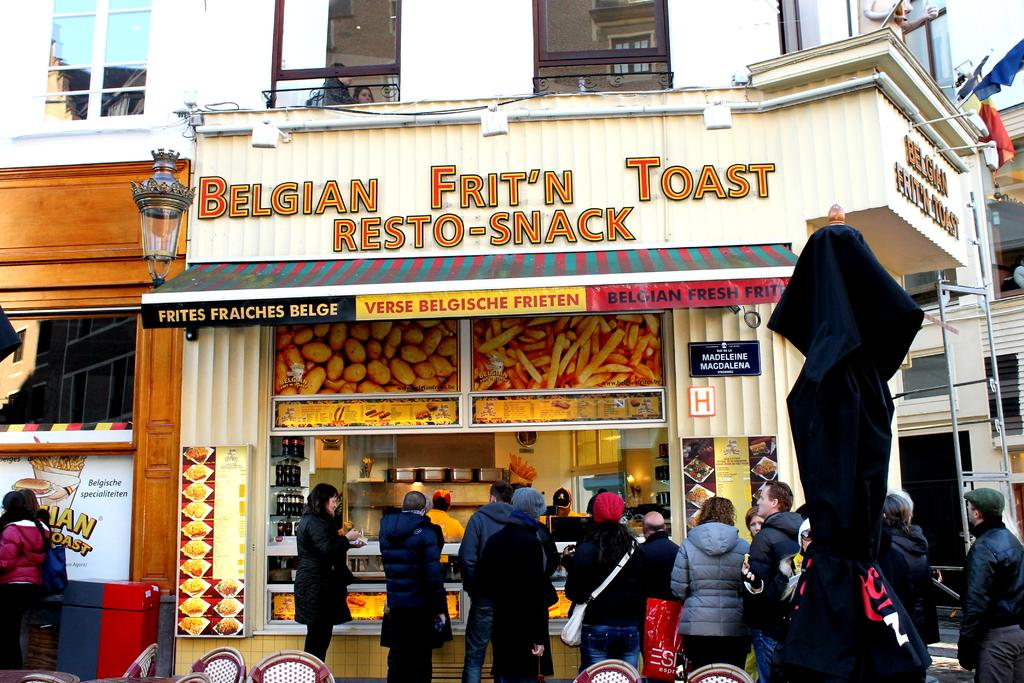What type of establishment is depicted in the image? There is a store in the image. Can you describe the people in the image? There are people standing at the bottom of the image. What can be seen on the right side of the image? There are flags on the right side of the image. What type of dress is the snail wearing in the image? There are no snails or dresses present in the image. 